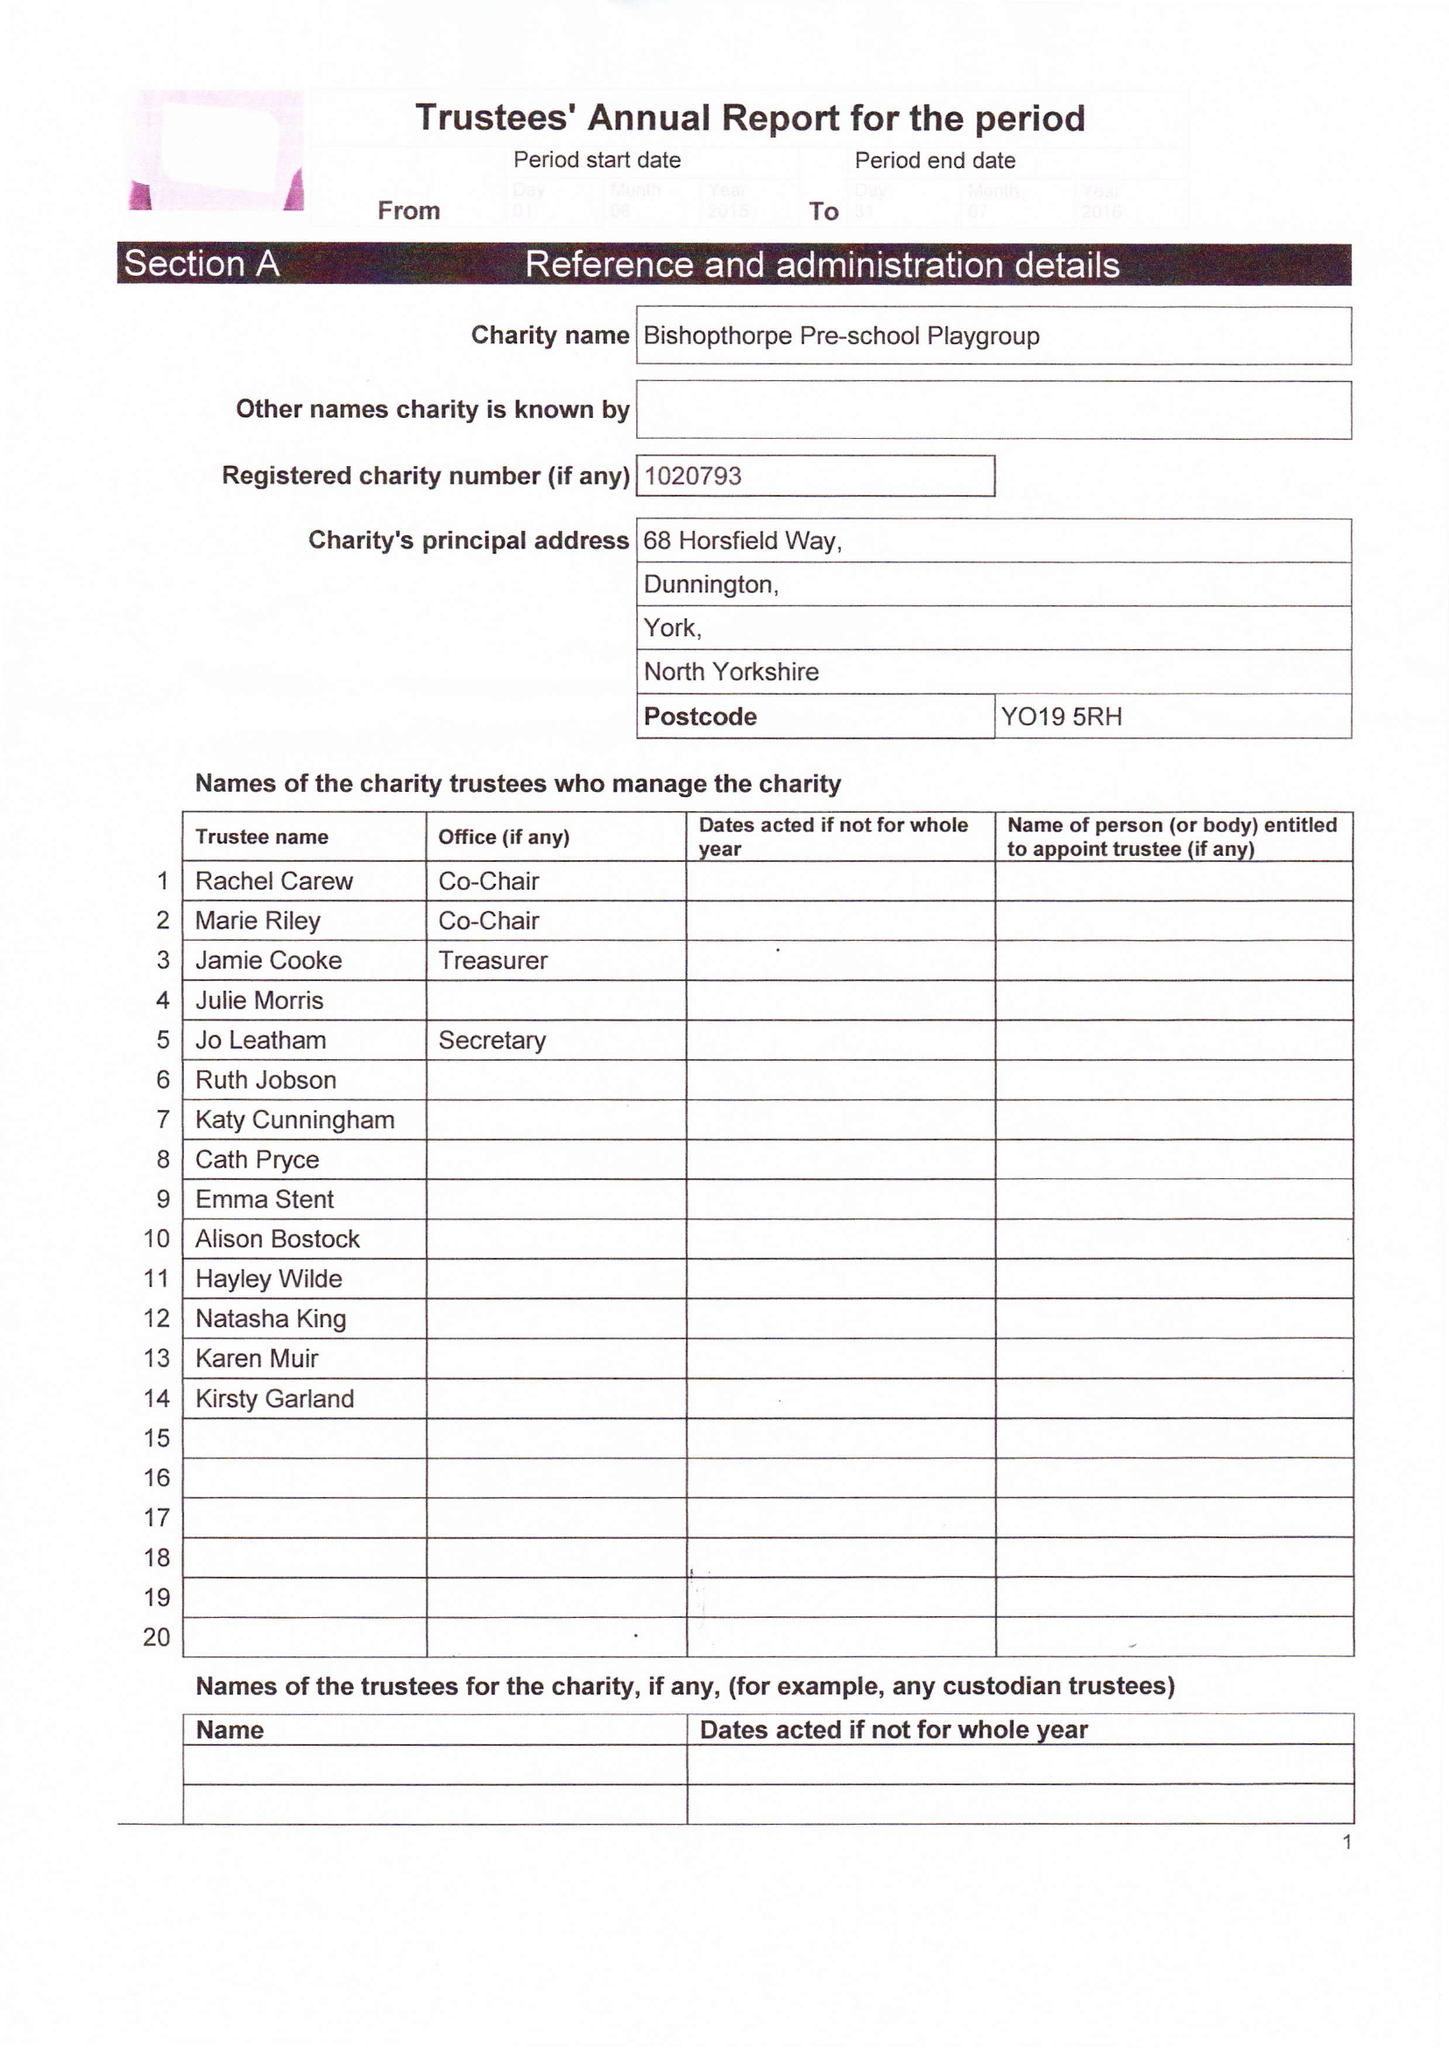What is the value for the charity_name?
Answer the question using a single word or phrase. Bishopthorpe Pre School Playgroup 